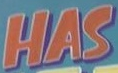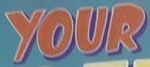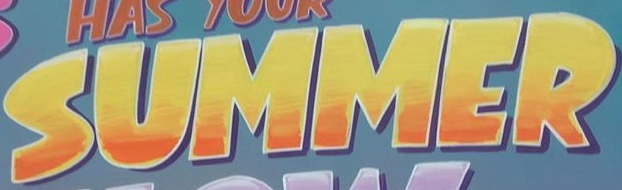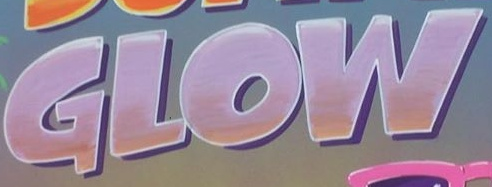Transcribe the words shown in these images in order, separated by a semicolon. HAS; YOUR; SUMMER; GLOW 